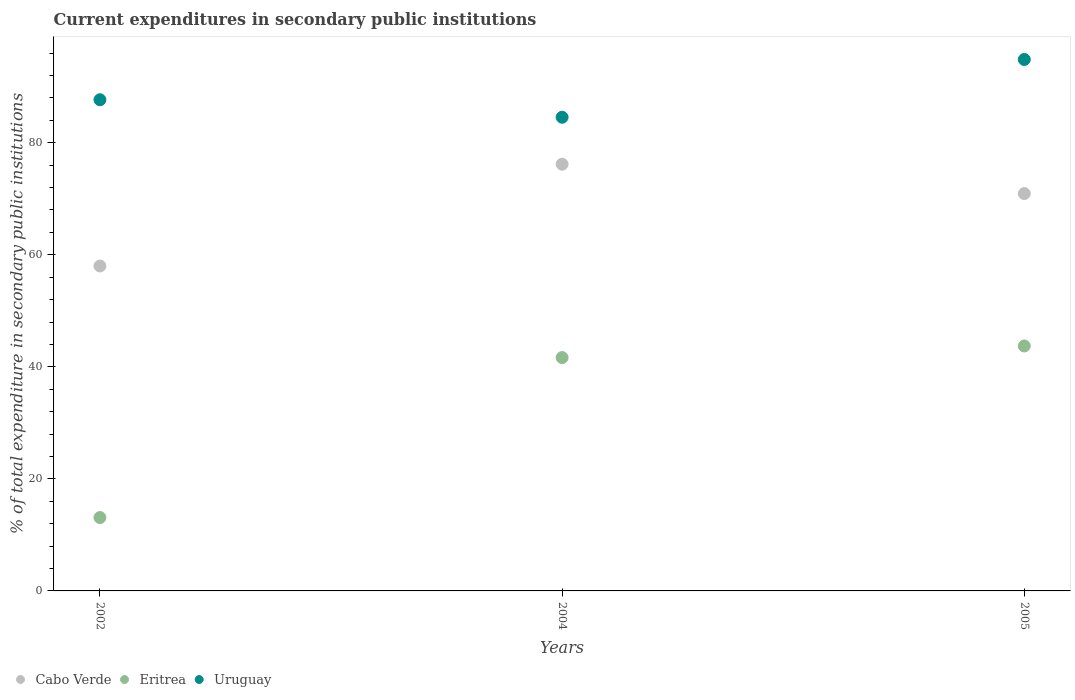What is the current expenditures in secondary public institutions in Cabo Verde in 2002?
Your answer should be compact. 58. Across all years, what is the maximum current expenditures in secondary public institutions in Eritrea?
Keep it short and to the point. 43.72. Across all years, what is the minimum current expenditures in secondary public institutions in Cabo Verde?
Make the answer very short. 58. In which year was the current expenditures in secondary public institutions in Eritrea minimum?
Make the answer very short. 2002. What is the total current expenditures in secondary public institutions in Eritrea in the graph?
Provide a short and direct response. 98.47. What is the difference between the current expenditures in secondary public institutions in Eritrea in 2002 and that in 2004?
Make the answer very short. -28.55. What is the difference between the current expenditures in secondary public institutions in Uruguay in 2002 and the current expenditures in secondary public institutions in Cabo Verde in 2005?
Make the answer very short. 16.75. What is the average current expenditures in secondary public institutions in Cabo Verde per year?
Keep it short and to the point. 68.36. In the year 2004, what is the difference between the current expenditures in secondary public institutions in Uruguay and current expenditures in secondary public institutions in Eritrea?
Keep it short and to the point. 42.9. In how many years, is the current expenditures in secondary public institutions in Eritrea greater than 60 %?
Give a very brief answer. 0. What is the ratio of the current expenditures in secondary public institutions in Cabo Verde in 2004 to that in 2005?
Provide a succinct answer. 1.07. Is the current expenditures in secondary public institutions in Cabo Verde in 2002 less than that in 2004?
Your response must be concise. Yes. Is the difference between the current expenditures in secondary public institutions in Uruguay in 2002 and 2004 greater than the difference between the current expenditures in secondary public institutions in Eritrea in 2002 and 2004?
Offer a very short reply. Yes. What is the difference between the highest and the second highest current expenditures in secondary public institutions in Cabo Verde?
Ensure brevity in your answer.  5.24. What is the difference between the highest and the lowest current expenditures in secondary public institutions in Eritrea?
Provide a succinct answer. 30.63. In how many years, is the current expenditures in secondary public institutions in Uruguay greater than the average current expenditures in secondary public institutions in Uruguay taken over all years?
Make the answer very short. 1. Is it the case that in every year, the sum of the current expenditures in secondary public institutions in Uruguay and current expenditures in secondary public institutions in Cabo Verde  is greater than the current expenditures in secondary public institutions in Eritrea?
Give a very brief answer. Yes. Does the current expenditures in secondary public institutions in Cabo Verde monotonically increase over the years?
Keep it short and to the point. No. How many years are there in the graph?
Ensure brevity in your answer.  3. Are the values on the major ticks of Y-axis written in scientific E-notation?
Provide a succinct answer. No. How are the legend labels stacked?
Provide a short and direct response. Horizontal. What is the title of the graph?
Make the answer very short. Current expenditures in secondary public institutions. Does "Cote d'Ivoire" appear as one of the legend labels in the graph?
Provide a short and direct response. No. What is the label or title of the Y-axis?
Your answer should be compact. % of total expenditure in secondary public institutions. What is the % of total expenditure in secondary public institutions of Cabo Verde in 2002?
Keep it short and to the point. 58. What is the % of total expenditure in secondary public institutions in Eritrea in 2002?
Your answer should be compact. 13.1. What is the % of total expenditure in secondary public institutions in Uruguay in 2002?
Your answer should be compact. 87.67. What is the % of total expenditure in secondary public institutions of Cabo Verde in 2004?
Your answer should be compact. 76.17. What is the % of total expenditure in secondary public institutions of Eritrea in 2004?
Provide a succinct answer. 41.65. What is the % of total expenditure in secondary public institutions in Uruguay in 2004?
Offer a very short reply. 84.55. What is the % of total expenditure in secondary public institutions in Cabo Verde in 2005?
Ensure brevity in your answer.  70.92. What is the % of total expenditure in secondary public institutions of Eritrea in 2005?
Keep it short and to the point. 43.72. What is the % of total expenditure in secondary public institutions of Uruguay in 2005?
Your response must be concise. 94.86. Across all years, what is the maximum % of total expenditure in secondary public institutions in Cabo Verde?
Provide a short and direct response. 76.17. Across all years, what is the maximum % of total expenditure in secondary public institutions of Eritrea?
Your answer should be compact. 43.72. Across all years, what is the maximum % of total expenditure in secondary public institutions in Uruguay?
Keep it short and to the point. 94.86. Across all years, what is the minimum % of total expenditure in secondary public institutions in Cabo Verde?
Your answer should be compact. 58. Across all years, what is the minimum % of total expenditure in secondary public institutions of Eritrea?
Offer a very short reply. 13.1. Across all years, what is the minimum % of total expenditure in secondary public institutions in Uruguay?
Keep it short and to the point. 84.55. What is the total % of total expenditure in secondary public institutions of Cabo Verde in the graph?
Provide a short and direct response. 205.09. What is the total % of total expenditure in secondary public institutions of Eritrea in the graph?
Give a very brief answer. 98.47. What is the total % of total expenditure in secondary public institutions of Uruguay in the graph?
Give a very brief answer. 267.08. What is the difference between the % of total expenditure in secondary public institutions of Cabo Verde in 2002 and that in 2004?
Offer a very short reply. -18.17. What is the difference between the % of total expenditure in secondary public institutions in Eritrea in 2002 and that in 2004?
Ensure brevity in your answer.  -28.55. What is the difference between the % of total expenditure in secondary public institutions of Uruguay in 2002 and that in 2004?
Offer a very short reply. 3.12. What is the difference between the % of total expenditure in secondary public institutions of Cabo Verde in 2002 and that in 2005?
Give a very brief answer. -12.93. What is the difference between the % of total expenditure in secondary public institutions in Eritrea in 2002 and that in 2005?
Your response must be concise. -30.63. What is the difference between the % of total expenditure in secondary public institutions in Uruguay in 2002 and that in 2005?
Offer a very short reply. -7.19. What is the difference between the % of total expenditure in secondary public institutions in Cabo Verde in 2004 and that in 2005?
Provide a short and direct response. 5.24. What is the difference between the % of total expenditure in secondary public institutions in Eritrea in 2004 and that in 2005?
Your answer should be compact. -2.07. What is the difference between the % of total expenditure in secondary public institutions in Uruguay in 2004 and that in 2005?
Offer a very short reply. -10.31. What is the difference between the % of total expenditure in secondary public institutions of Cabo Verde in 2002 and the % of total expenditure in secondary public institutions of Eritrea in 2004?
Provide a short and direct response. 16.34. What is the difference between the % of total expenditure in secondary public institutions of Cabo Verde in 2002 and the % of total expenditure in secondary public institutions of Uruguay in 2004?
Ensure brevity in your answer.  -26.55. What is the difference between the % of total expenditure in secondary public institutions of Eritrea in 2002 and the % of total expenditure in secondary public institutions of Uruguay in 2004?
Ensure brevity in your answer.  -71.45. What is the difference between the % of total expenditure in secondary public institutions of Cabo Verde in 2002 and the % of total expenditure in secondary public institutions of Eritrea in 2005?
Offer a terse response. 14.27. What is the difference between the % of total expenditure in secondary public institutions of Cabo Verde in 2002 and the % of total expenditure in secondary public institutions of Uruguay in 2005?
Provide a short and direct response. -36.86. What is the difference between the % of total expenditure in secondary public institutions in Eritrea in 2002 and the % of total expenditure in secondary public institutions in Uruguay in 2005?
Make the answer very short. -81.76. What is the difference between the % of total expenditure in secondary public institutions in Cabo Verde in 2004 and the % of total expenditure in secondary public institutions in Eritrea in 2005?
Offer a very short reply. 32.44. What is the difference between the % of total expenditure in secondary public institutions of Cabo Verde in 2004 and the % of total expenditure in secondary public institutions of Uruguay in 2005?
Keep it short and to the point. -18.69. What is the difference between the % of total expenditure in secondary public institutions of Eritrea in 2004 and the % of total expenditure in secondary public institutions of Uruguay in 2005?
Your response must be concise. -53.21. What is the average % of total expenditure in secondary public institutions in Cabo Verde per year?
Give a very brief answer. 68.36. What is the average % of total expenditure in secondary public institutions of Eritrea per year?
Your answer should be compact. 32.82. What is the average % of total expenditure in secondary public institutions of Uruguay per year?
Ensure brevity in your answer.  89.03. In the year 2002, what is the difference between the % of total expenditure in secondary public institutions in Cabo Verde and % of total expenditure in secondary public institutions in Eritrea?
Make the answer very short. 44.9. In the year 2002, what is the difference between the % of total expenditure in secondary public institutions of Cabo Verde and % of total expenditure in secondary public institutions of Uruguay?
Keep it short and to the point. -29.67. In the year 2002, what is the difference between the % of total expenditure in secondary public institutions in Eritrea and % of total expenditure in secondary public institutions in Uruguay?
Give a very brief answer. -74.57. In the year 2004, what is the difference between the % of total expenditure in secondary public institutions in Cabo Verde and % of total expenditure in secondary public institutions in Eritrea?
Offer a terse response. 34.52. In the year 2004, what is the difference between the % of total expenditure in secondary public institutions in Cabo Verde and % of total expenditure in secondary public institutions in Uruguay?
Make the answer very short. -8.38. In the year 2004, what is the difference between the % of total expenditure in secondary public institutions of Eritrea and % of total expenditure in secondary public institutions of Uruguay?
Provide a succinct answer. -42.9. In the year 2005, what is the difference between the % of total expenditure in secondary public institutions of Cabo Verde and % of total expenditure in secondary public institutions of Eritrea?
Offer a very short reply. 27.2. In the year 2005, what is the difference between the % of total expenditure in secondary public institutions in Cabo Verde and % of total expenditure in secondary public institutions in Uruguay?
Your response must be concise. -23.94. In the year 2005, what is the difference between the % of total expenditure in secondary public institutions of Eritrea and % of total expenditure in secondary public institutions of Uruguay?
Provide a short and direct response. -51.13. What is the ratio of the % of total expenditure in secondary public institutions in Cabo Verde in 2002 to that in 2004?
Your answer should be compact. 0.76. What is the ratio of the % of total expenditure in secondary public institutions of Eritrea in 2002 to that in 2004?
Your answer should be very brief. 0.31. What is the ratio of the % of total expenditure in secondary public institutions in Uruguay in 2002 to that in 2004?
Provide a succinct answer. 1.04. What is the ratio of the % of total expenditure in secondary public institutions of Cabo Verde in 2002 to that in 2005?
Keep it short and to the point. 0.82. What is the ratio of the % of total expenditure in secondary public institutions in Eritrea in 2002 to that in 2005?
Offer a very short reply. 0.3. What is the ratio of the % of total expenditure in secondary public institutions of Uruguay in 2002 to that in 2005?
Ensure brevity in your answer.  0.92. What is the ratio of the % of total expenditure in secondary public institutions of Cabo Verde in 2004 to that in 2005?
Keep it short and to the point. 1.07. What is the ratio of the % of total expenditure in secondary public institutions of Eritrea in 2004 to that in 2005?
Offer a very short reply. 0.95. What is the ratio of the % of total expenditure in secondary public institutions in Uruguay in 2004 to that in 2005?
Your answer should be very brief. 0.89. What is the difference between the highest and the second highest % of total expenditure in secondary public institutions in Cabo Verde?
Offer a terse response. 5.24. What is the difference between the highest and the second highest % of total expenditure in secondary public institutions in Eritrea?
Offer a very short reply. 2.07. What is the difference between the highest and the second highest % of total expenditure in secondary public institutions in Uruguay?
Offer a very short reply. 7.19. What is the difference between the highest and the lowest % of total expenditure in secondary public institutions in Cabo Verde?
Ensure brevity in your answer.  18.17. What is the difference between the highest and the lowest % of total expenditure in secondary public institutions in Eritrea?
Provide a short and direct response. 30.63. What is the difference between the highest and the lowest % of total expenditure in secondary public institutions in Uruguay?
Provide a short and direct response. 10.31. 